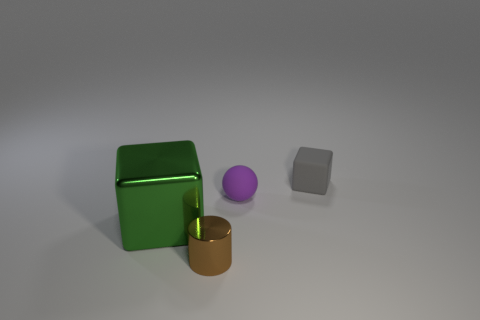What is the size of the green object? The green object appears to be of medium size relative to the other objects in the image, specifically larger than the small purple sphere and the tiny gold cylinder, but smaller than the grey cube. 